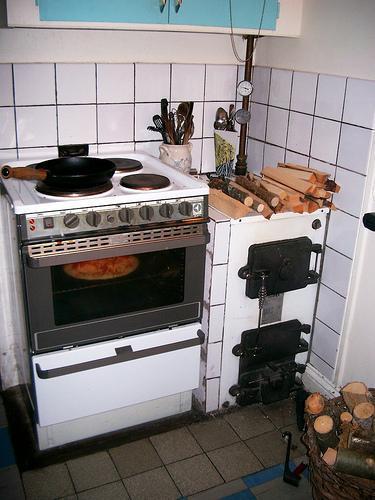How many knobs are on the oven?
Give a very brief answer. 6. How many pizzas are on the racks?
Give a very brief answer. 1. How many people are sitting down on chairs?
Give a very brief answer. 0. 